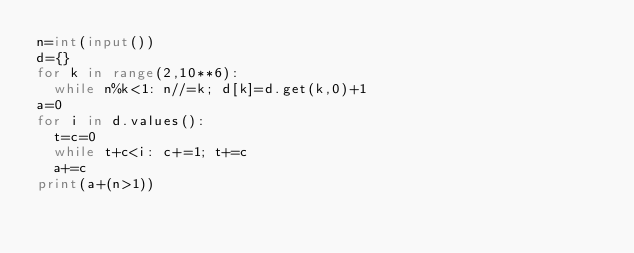Convert code to text. <code><loc_0><loc_0><loc_500><loc_500><_Python_>n=int(input())
d={}
for k in range(2,10**6):
  while n%k<1: n//=k; d[k]=d.get(k,0)+1
a=0
for i in d.values():
  t=c=0
  while t+c<i: c+=1; t+=c
  a+=c
print(a+(n>1))</code> 